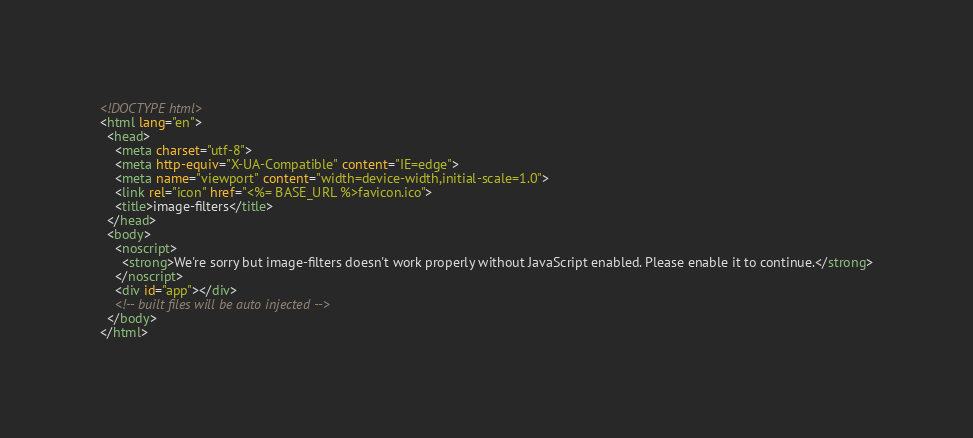Convert code to text. <code><loc_0><loc_0><loc_500><loc_500><_HTML_><!DOCTYPE html>
<html lang="en">
  <head>
    <meta charset="utf-8">
    <meta http-equiv="X-UA-Compatible" content="IE=edge">
    <meta name="viewport" content="width=device-width,initial-scale=1.0">
    <link rel="icon" href="<%= BASE_URL %>favicon.ico">
    <title>image-filters</title>
  </head>
  <body>
    <noscript>
      <strong>We're sorry but image-filters doesn't work properly without JavaScript enabled. Please enable it to continue.</strong>
    </noscript>
    <div id="app"></div>
    <!-- built files will be auto injected -->
  </body>
</html>
</code> 